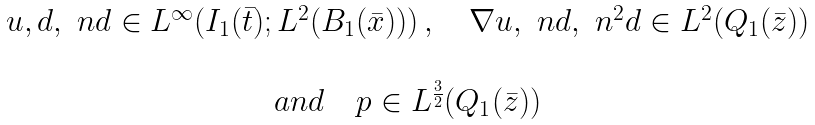Convert formula to latex. <formula><loc_0><loc_0><loc_500><loc_500>\begin{array} { c } u , d , \ n d \in L ^ { \infty } ( I _ { 1 } ( \bar { t } ) ; L ^ { 2 } ( B _ { 1 } ( \bar { x } ) ) ) \, , \quad \nabla u , \ n d , \ n ^ { 2 } d \in L ^ { 2 } ( Q _ { 1 } ( \bar { z } ) ) \\ \\ a n d \quad p \in L ^ { \frac { 3 } { 2 } } ( Q _ { 1 } ( \bar { z } ) ) \end{array}</formula> 